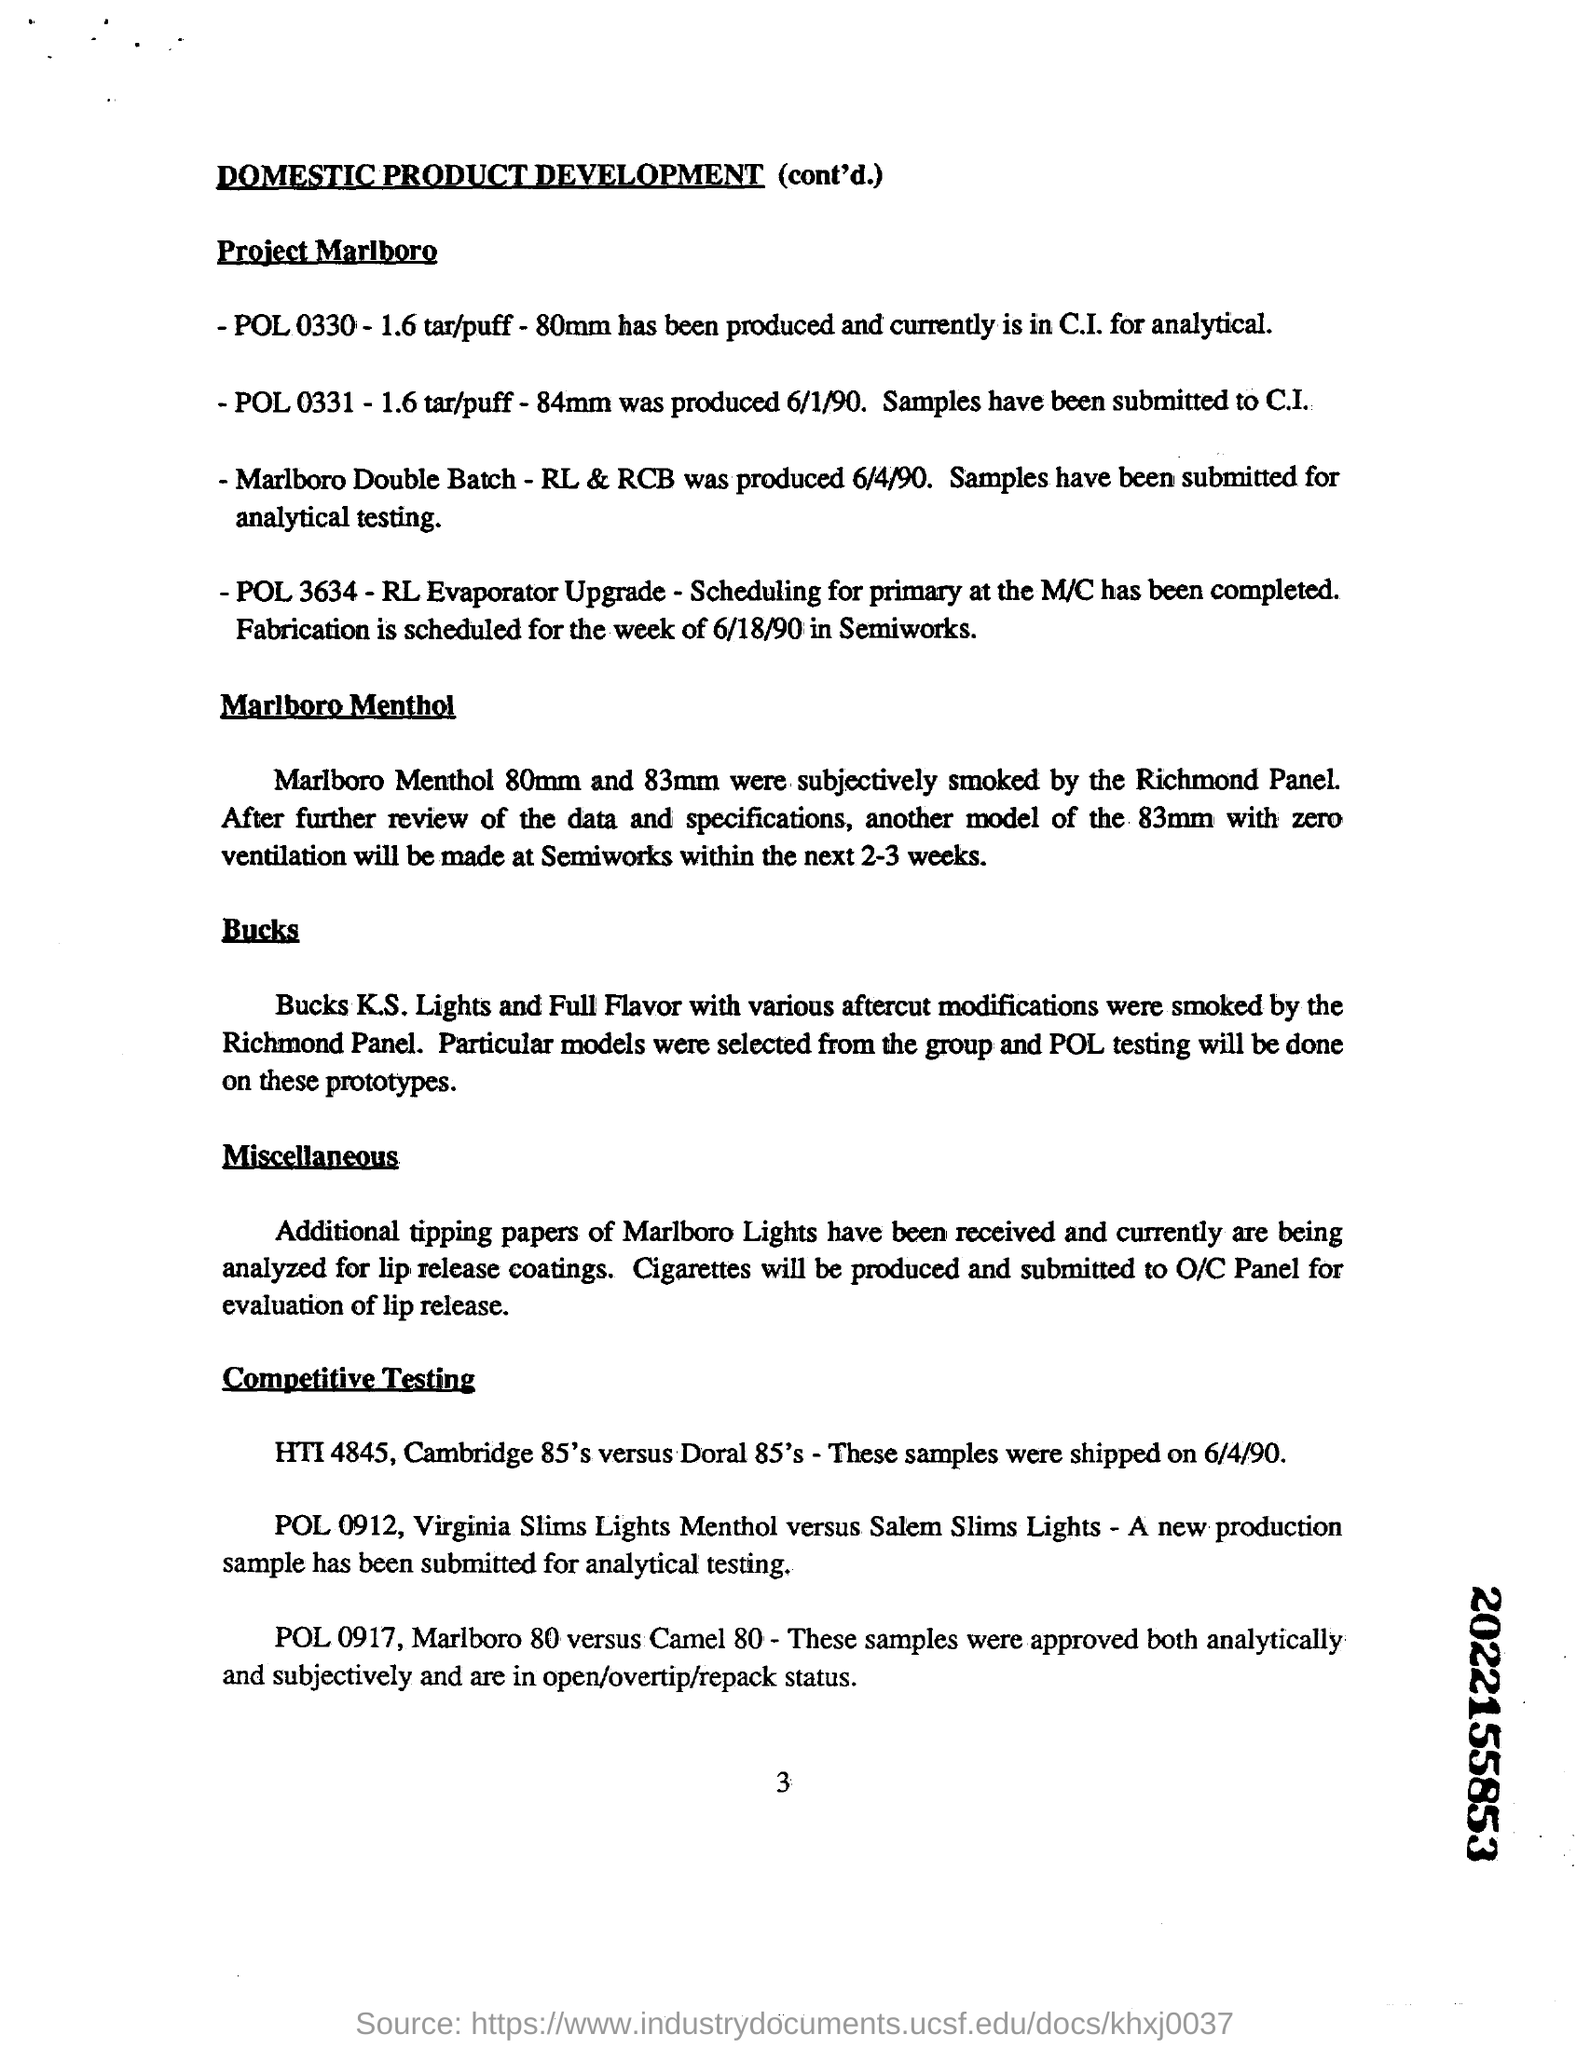Point out several critical features in this image. It is the intention of the manufacturer to produce and submit cigarettes to the O/C Panel for evaluation of the lip release. Semiworks will produce another model of the 83mm with zero ventilation within the next 2-3 weeks. The Richmond Panel reported subjectively smoking cigarettes with sizes of 80mm and 83mm Marlboro Menthol. The heading of the document is 'Domestic Product Development (cont'd.).'. 